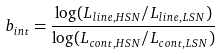Convert formula to latex. <formula><loc_0><loc_0><loc_500><loc_500>b _ { i n t } = \frac { \log ( L _ { l i n e , H S N } / L _ { l i n e , L S N } ) } { \log ( L _ { c o n t , H S N } / L _ { c o n t , L S N } ) }</formula> 